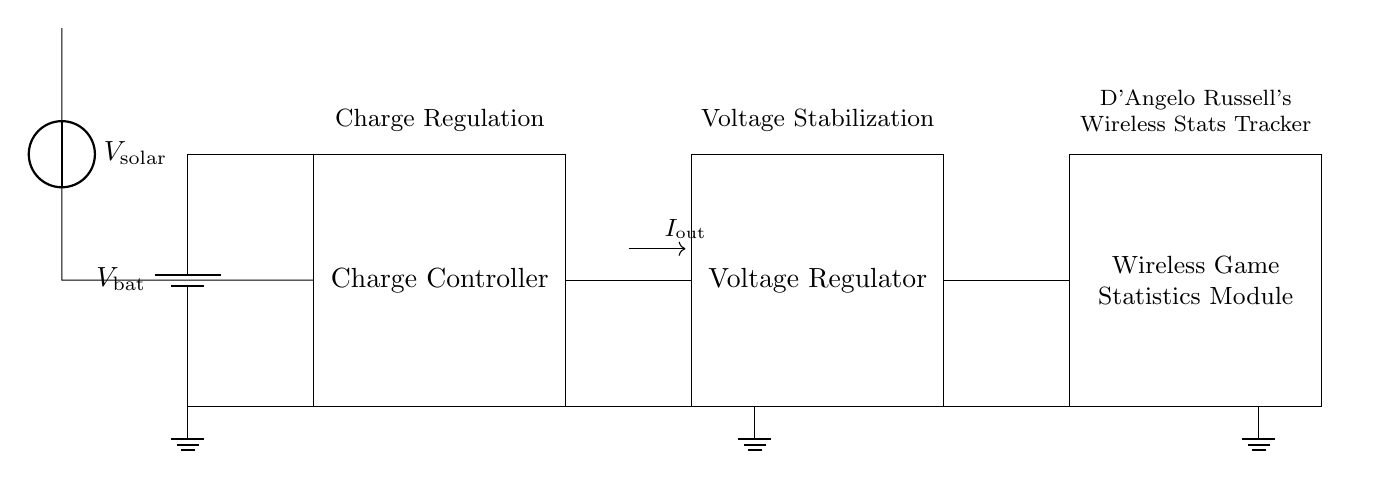What component regulates voltage in this circuit? The voltage regulator, which stabilizes the output voltage to a desired level for the wireless module.
Answer: Voltage Regulator What is the purpose of the charge controller? The charge controller manages the power coming from the solar panel to ensure the battery charges correctly without overcharging.
Answer: Charge Controller What does the solar panel supply? The solar panel supplies the input voltage, which is typically used to charge the battery or power the circuit.
Answer: V solar What is the output current direction indicated by the arrow? The arrow labeled I out shows the direction of the output current flowing towards the wireless game statistics module.
Answer: I out Why is there a ground symbol in the circuit? The ground symbol connects the circuit to a common reference point for voltage levels, ensuring proper operation of all components.
Answer: Ground How many main components are in the circuit? The circuit includes four main components: battery, charge controller, voltage regulator, and wireless module, which are necessary for its function.
Answer: Four What is the device connected to the output of the voltage regulator? The wireless game statistics module receives regulated voltage output from the voltage regulator to function properly in tracking game stats.
Answer: Wireless Game Statistics Module 